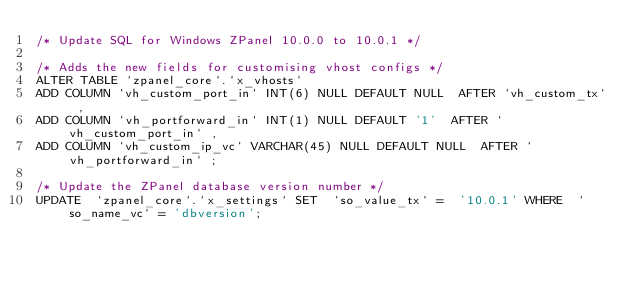<code> <loc_0><loc_0><loc_500><loc_500><_SQL_>/* Update SQL for Windows ZPanel 10.0.0 to 10.0.1 */

/* Adds the new fields for customising vhost configs */
ALTER TABLE `zpanel_core`.`x_vhosts` 
ADD COLUMN `vh_custom_port_in` INT(6) NULL DEFAULT NULL  AFTER `vh_custom_tx` , 
ADD COLUMN `vh_portforward_in` INT(1) NULL DEFAULT '1'  AFTER `vh_custom_port_in` , 
ADD COLUMN `vh_custom_ip_vc` VARCHAR(45) NULL DEFAULT NULL  AFTER `vh_portforward_in` ;

/* Update the ZPanel database version number */
UPDATE  `zpanel_core`.`x_settings` SET  `so_value_tx` =  '10.0.1' WHERE  `so_name_vc` = 'dbversion';







</code> 